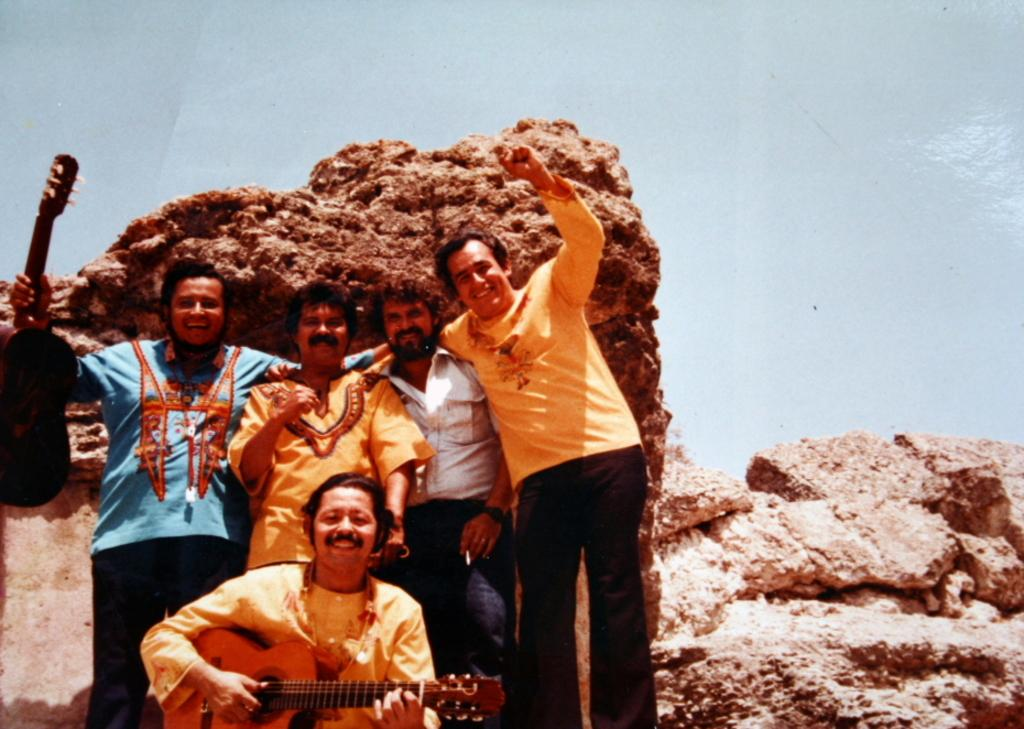What is the main subject of the image? The main subject of the image is a group of people. What are the people in the image doing? Some people are standing, and some people are sitting. Is there any musical instrument present in the image? Yes, at least one person is holding a guitar. How many deer can be seen in the image? There are no deer present in the image; it features a group of people. What color are the eyes of the person holding the guitar? The image does not provide enough detail to determine the color of the eyes of the person holding the guitar. 